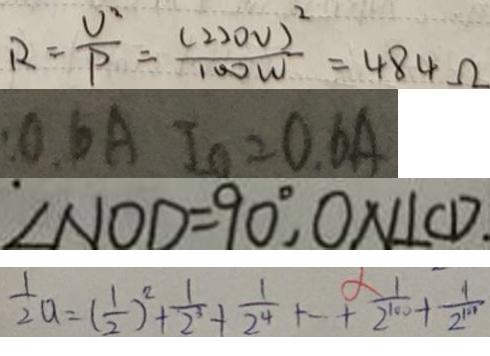<formula> <loc_0><loc_0><loc_500><loc_500>R = \frac { U ^ { 2 } } { P } = \frac { ( 2 2 0 V ) ^ { 2 } } { 1 0 0 W } = 4 8 4 \Omega 
 0 . 6 A I _ { 0 } = 0 . 6 A 
 \angle N O D = 9 0 ^ { \circ } , O N \bot C D _ { \cdot } 
 \frac { 1 } { 2 } a = ( \frac { 1 } { 2 } ) ^ { 2 } + \frac { 1 } { 2 ^ { 3 } } + \frac { 1 } { 2 ^ { 4 } } + \cdots + \frac { 1 } { 2 ^ { 1 0 0 } } + \frac { 1 } { 2 ^ { 1 0 1 } }</formula> 